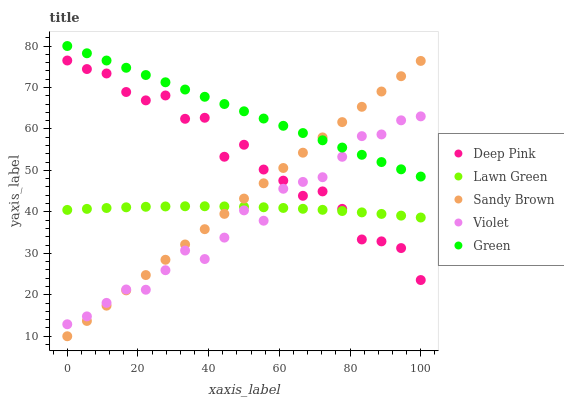Does Violet have the minimum area under the curve?
Answer yes or no. Yes. Does Green have the maximum area under the curve?
Answer yes or no. Yes. Does Deep Pink have the minimum area under the curve?
Answer yes or no. No. Does Deep Pink have the maximum area under the curve?
Answer yes or no. No. Is Green the smoothest?
Answer yes or no. Yes. Is Deep Pink the roughest?
Answer yes or no. Yes. Is Sandy Brown the smoothest?
Answer yes or no. No. Is Sandy Brown the roughest?
Answer yes or no. No. Does Sandy Brown have the lowest value?
Answer yes or no. Yes. Does Deep Pink have the lowest value?
Answer yes or no. No. Does Green have the highest value?
Answer yes or no. Yes. Does Deep Pink have the highest value?
Answer yes or no. No. Is Deep Pink less than Green?
Answer yes or no. Yes. Is Green greater than Lawn Green?
Answer yes or no. Yes. Does Lawn Green intersect Deep Pink?
Answer yes or no. Yes. Is Lawn Green less than Deep Pink?
Answer yes or no. No. Is Lawn Green greater than Deep Pink?
Answer yes or no. No. Does Deep Pink intersect Green?
Answer yes or no. No. 